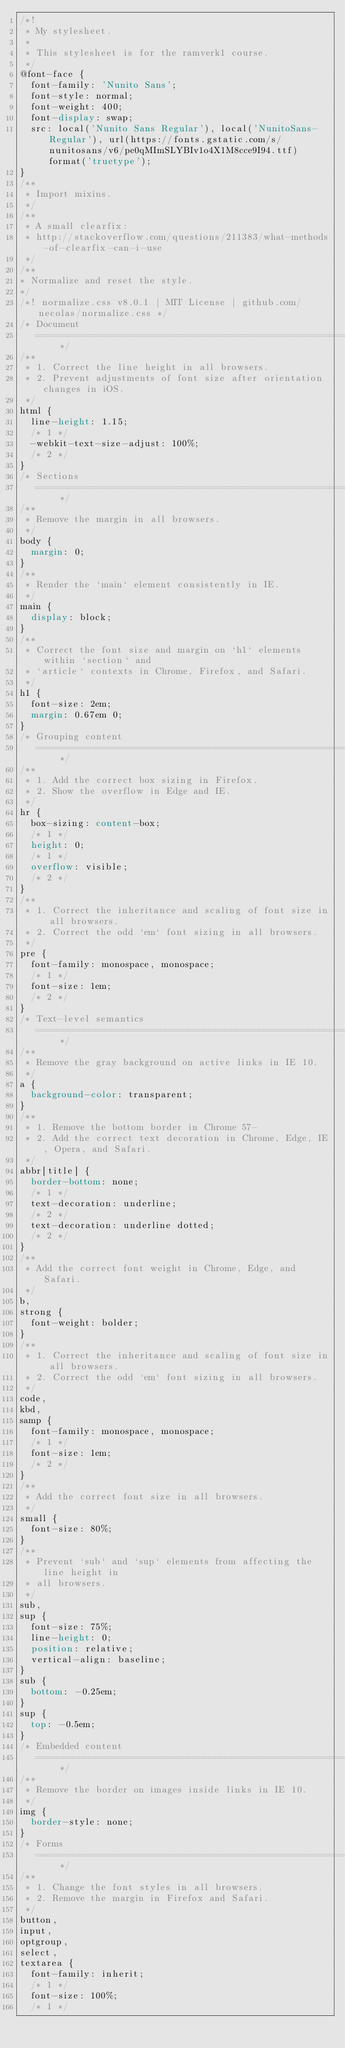Convert code to text. <code><loc_0><loc_0><loc_500><loc_500><_CSS_>/*!
 * My stylesheet.
 *
 * This stylesheet is for the ramverk1 course.
 */
@font-face {
  font-family: 'Nunito Sans';
  font-style: normal;
  font-weight: 400;
  font-display: swap;
  src: local('Nunito Sans Regular'), local('NunitoSans-Regular'), url(https://fonts.gstatic.com/s/nunitosans/v6/pe0qMImSLYBIv1o4X1M8cce9I94.ttf) format('truetype');
}
/**
 * Import mixins.
 */
/**
 * A small clearfix:
 * http://stackoverflow.com/questions/211383/what-methods-of-clearfix-can-i-use
 */
/**
* Normalize and reset the style.
*/
/*! normalize.css v8.0.1 | MIT License | github.com/necolas/normalize.css */
/* Document
   ========================================================================== */
/**
 * 1. Correct the line height in all browsers.
 * 2. Prevent adjustments of font size after orientation changes in iOS.
 */
html {
  line-height: 1.15;
  /* 1 */
  -webkit-text-size-adjust: 100%;
  /* 2 */
}
/* Sections
   ========================================================================== */
/**
 * Remove the margin in all browsers.
 */
body {
  margin: 0;
}
/**
 * Render the `main` element consistently in IE.
 */
main {
  display: block;
}
/**
 * Correct the font size and margin on `h1` elements within `section` and
 * `article` contexts in Chrome, Firefox, and Safari.
 */
h1 {
  font-size: 2em;
  margin: 0.67em 0;
}
/* Grouping content
   ========================================================================== */
/**
 * 1. Add the correct box sizing in Firefox.
 * 2. Show the overflow in Edge and IE.
 */
hr {
  box-sizing: content-box;
  /* 1 */
  height: 0;
  /* 1 */
  overflow: visible;
  /* 2 */
}
/**
 * 1. Correct the inheritance and scaling of font size in all browsers.
 * 2. Correct the odd `em` font sizing in all browsers.
 */
pre {
  font-family: monospace, monospace;
  /* 1 */
  font-size: 1em;
  /* 2 */
}
/* Text-level semantics
   ========================================================================== */
/**
 * Remove the gray background on active links in IE 10.
 */
a {
  background-color: transparent;
}
/**
 * 1. Remove the bottom border in Chrome 57-
 * 2. Add the correct text decoration in Chrome, Edge, IE, Opera, and Safari.
 */
abbr[title] {
  border-bottom: none;
  /* 1 */
  text-decoration: underline;
  /* 2 */
  text-decoration: underline dotted;
  /* 2 */
}
/**
 * Add the correct font weight in Chrome, Edge, and Safari.
 */
b,
strong {
  font-weight: bolder;
}
/**
 * 1. Correct the inheritance and scaling of font size in all browsers.
 * 2. Correct the odd `em` font sizing in all browsers.
 */
code,
kbd,
samp {
  font-family: monospace, monospace;
  /* 1 */
  font-size: 1em;
  /* 2 */
}
/**
 * Add the correct font size in all browsers.
 */
small {
  font-size: 80%;
}
/**
 * Prevent `sub` and `sup` elements from affecting the line height in
 * all browsers.
 */
sub,
sup {
  font-size: 75%;
  line-height: 0;
  position: relative;
  vertical-align: baseline;
}
sub {
  bottom: -0.25em;
}
sup {
  top: -0.5em;
}
/* Embedded content
   ========================================================================== */
/**
 * Remove the border on images inside links in IE 10.
 */
img {
  border-style: none;
}
/* Forms
   ========================================================================== */
/**
 * 1. Change the font styles in all browsers.
 * 2. Remove the margin in Firefox and Safari.
 */
button,
input,
optgroup,
select,
textarea {
  font-family: inherit;
  /* 1 */
  font-size: 100%;
  /* 1 */</code> 